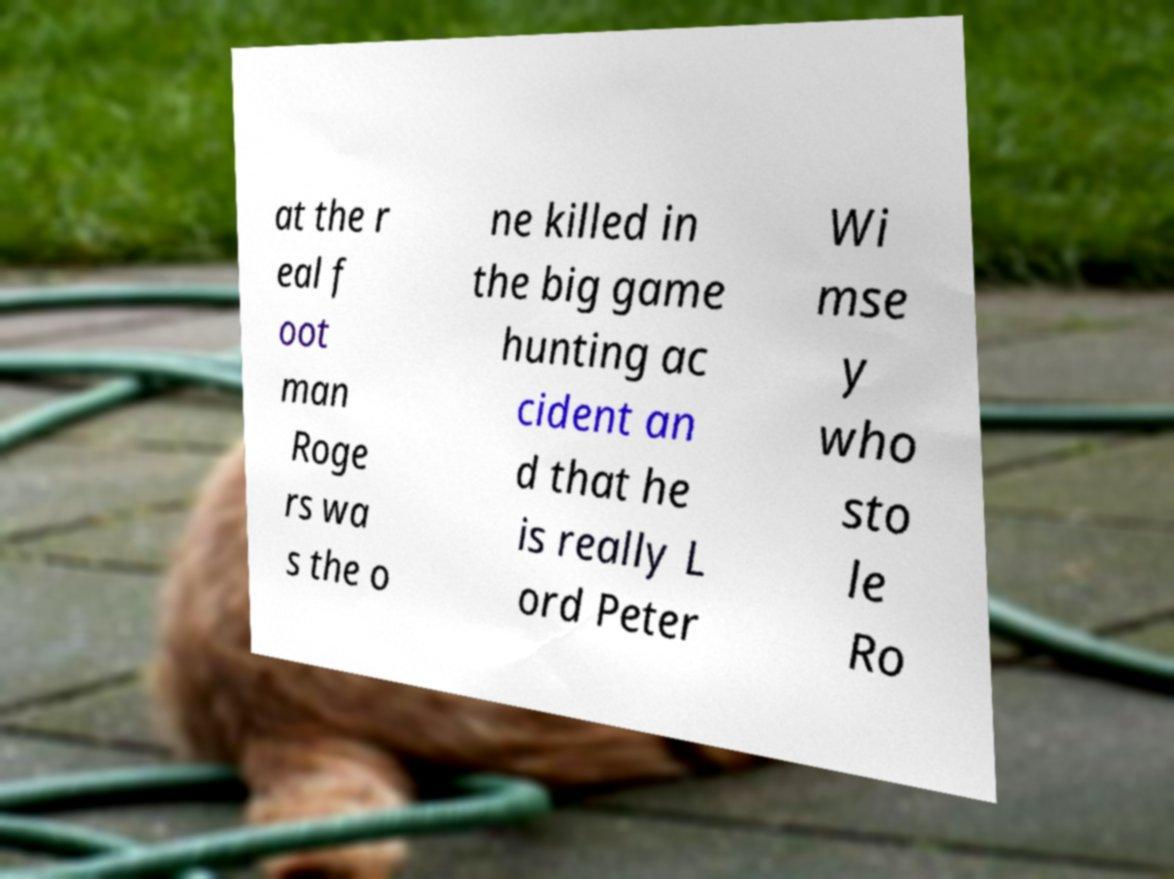Can you read and provide the text displayed in the image?This photo seems to have some interesting text. Can you extract and type it out for me? at the r eal f oot man Roge rs wa s the o ne killed in the big game hunting ac cident an d that he is really L ord Peter Wi mse y who sto le Ro 